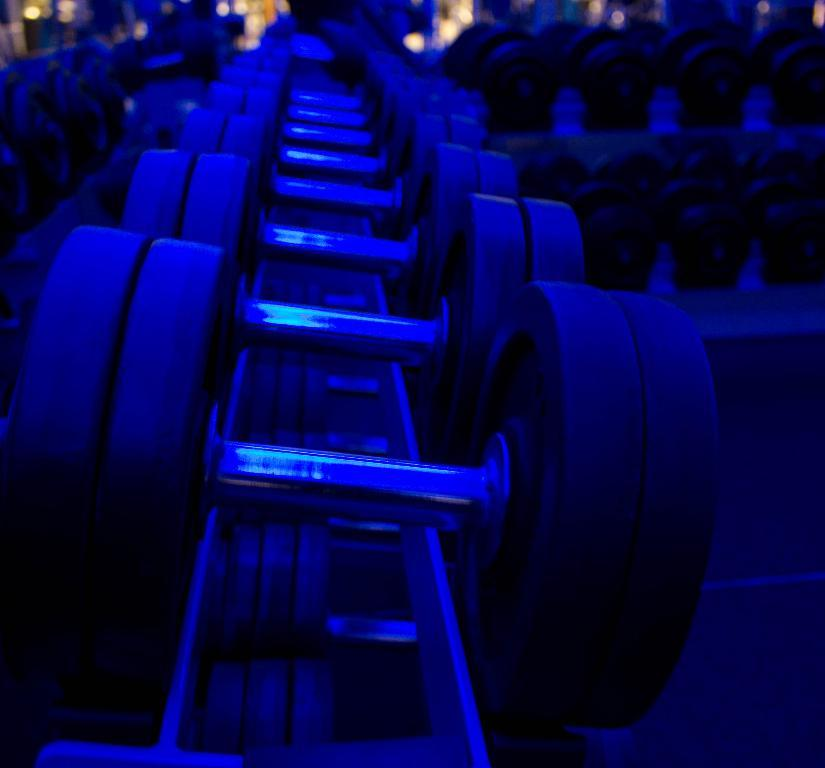Where was the image taken? The image was taken in a gym. What equipment can be seen in the foreground of the image? There are dumbbells in the foreground of the image. Can you describe the background of the image? The background of the image is blurred, and there are lights visible. Are there any other dumbbells in the image? Yes, there are additional dumbbells in the background of the image. What type of linen can be seen draped over the dumbbells in the image? There is no linen draped over the dumbbells in the image. How does the air circulate in the gym as depicted in the image? The image does not provide information about air circulation in the gym. 